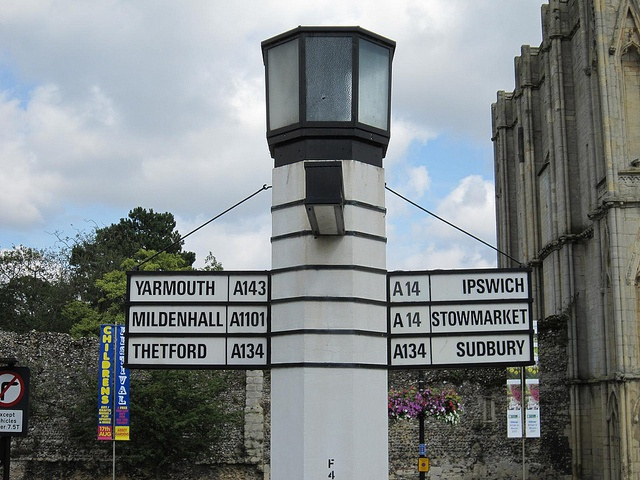Describe the objects in this image and their specific colors. I can see various objects in this image with different colors. 